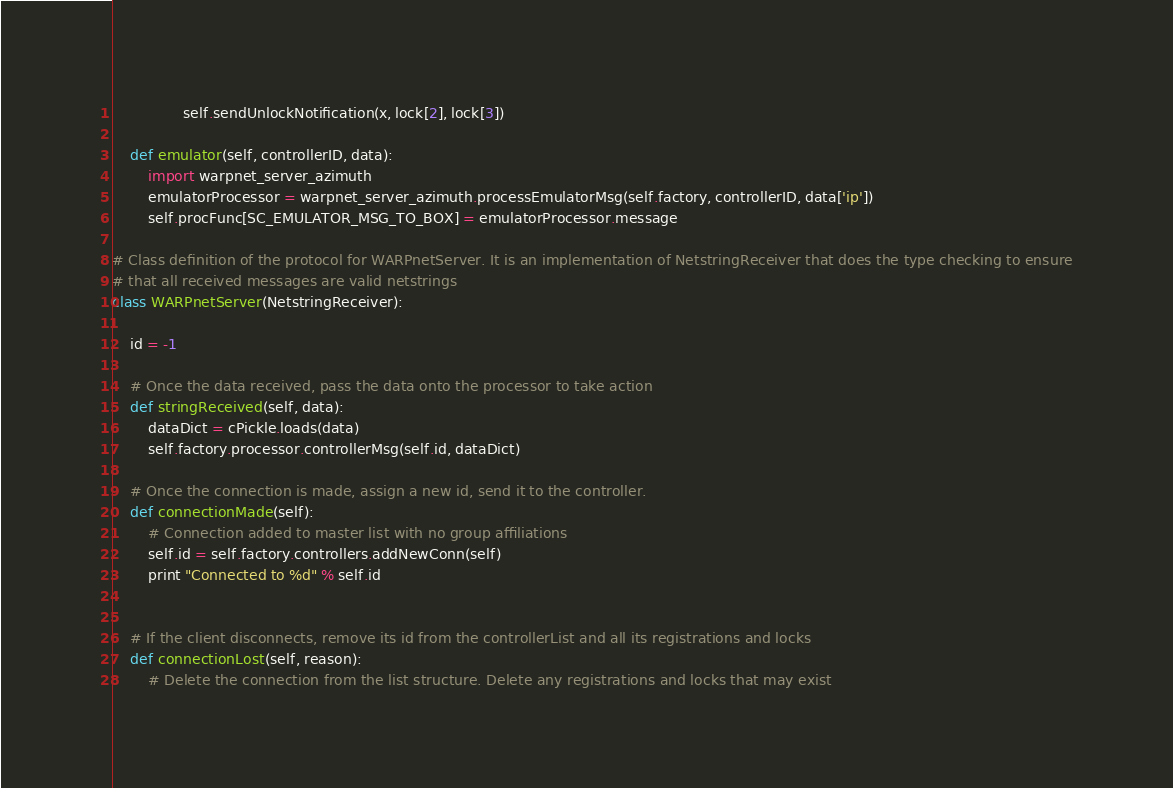<code> <loc_0><loc_0><loc_500><loc_500><_Python_>				self.sendUnlockNotification(x, lock[2], lock[3])
				
	def emulator(self, controllerID, data):
		import warpnet_server_azimuth
		emulatorProcessor = warpnet_server_azimuth.processEmulatorMsg(self.factory, controllerID, data['ip'])
		self.procFunc[SC_EMULATOR_MSG_TO_BOX] = emulatorProcessor.message
	
# Class definition of the protocol for WARPnetServer. It is an implementation of NetstringReceiver that does the type checking to ensure
# that all received messages are valid netstrings
class WARPnetServer(NetstringReceiver):

	id = -1

	# Once the data received, pass the data onto the processor to take action
	def stringReceived(self, data):
		dataDict = cPickle.loads(data)
		self.factory.processor.controllerMsg(self.id, dataDict)
	
	# Once the connection is made, assign a new id, send it to the controller.
	def connectionMade(self):
		# Connection added to master list with no group affiliations
		self.id = self.factory.controllers.addNewConn(self)
		print "Connected to %d" % self.id

		
	# If the client disconnects, remove its id from the controllerList and all its registrations and locks
	def connectionLost(self, reason):
		# Delete the connection from the list structure. Delete any registrations and locks that may exist</code> 